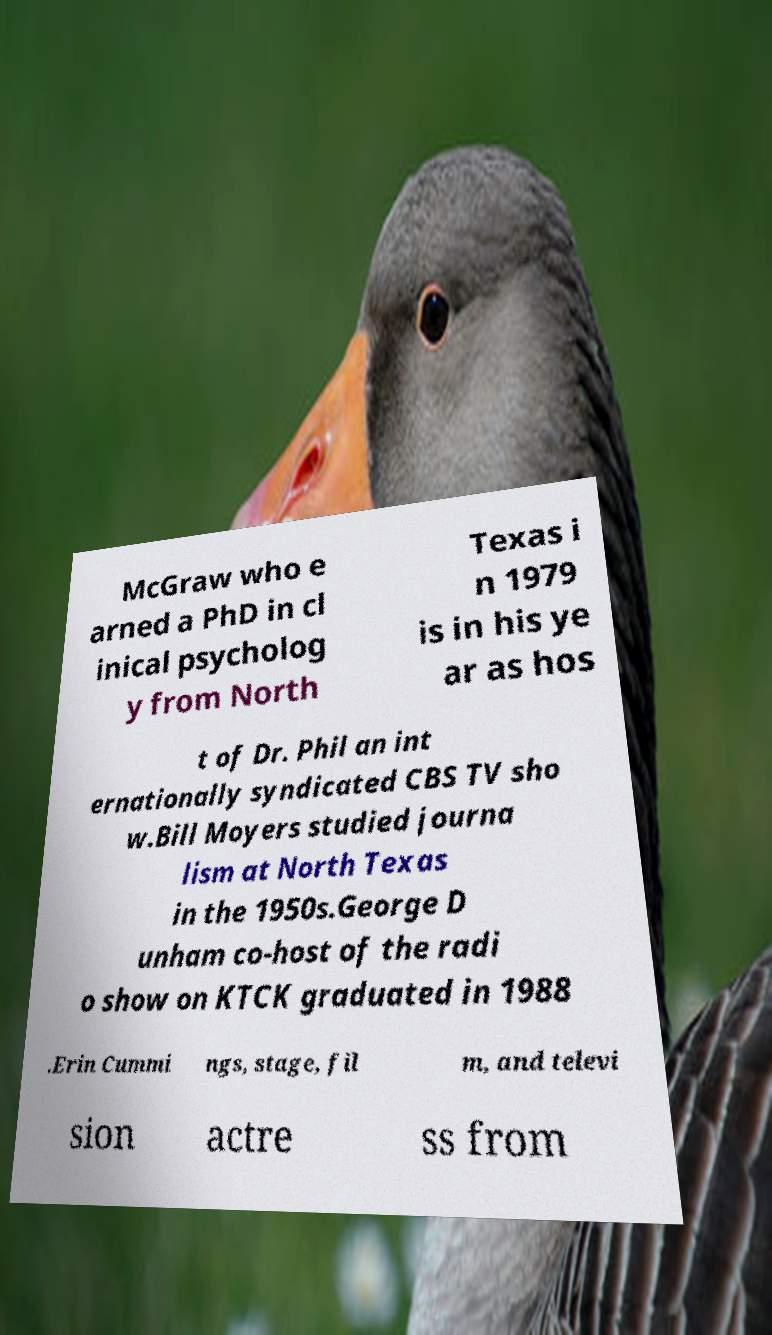For documentation purposes, I need the text within this image transcribed. Could you provide that? McGraw who e arned a PhD in cl inical psycholog y from North Texas i n 1979 is in his ye ar as hos t of Dr. Phil an int ernationally syndicated CBS TV sho w.Bill Moyers studied journa lism at North Texas in the 1950s.George D unham co-host of the radi o show on KTCK graduated in 1988 .Erin Cummi ngs, stage, fil m, and televi sion actre ss from 